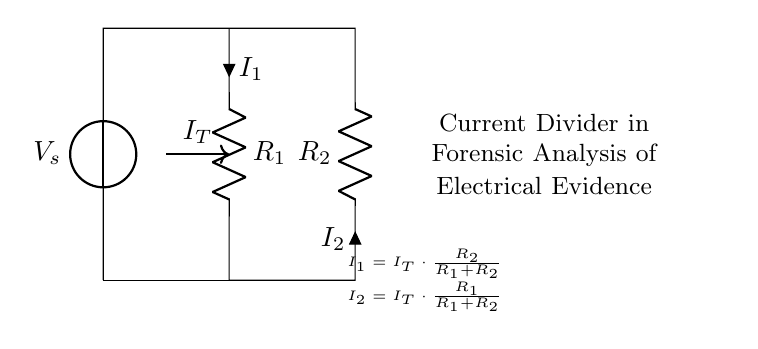What are the components present in this circuit? The components in this circuit are a voltage source and two resistors. The voltage source provides the potential difference, while the resistors divide the current.
Answer: Voltage source, two resistors What is the total current flowing in the circuit? The total current is represented as IT, which flows from the voltage source and splits between the two resistors.
Answer: IT How is current I1 related to total current IT and resistance values? Current I1 is given by the formula I1 = IT * (R2 / (R1 + R2)). This shows that I1 is directly proportional to the resistance of R2 and inversely proportional to the sum of both resistances.
Answer: IT * (R2 / (R1 + R2)) What is the relationship between currents I1 and I2? The currents I1 and I2 are inversely related to their respective resistances; as one increases, the other decreases, adhering to the principle of current division. This relationship can be expressed as I2 = IT * (R1 / (R1 + R2)).
Answer: Inversely related If R1 is 4 ohms and R2 is 2 ohms, what is the ratio of I1 to I2? To find the ratio, apply the formula: I1 / I2 = (R2 / R1) = (2 / 4) = 0.5. Thus the ratio of current I1 to I2 is 1:2, indicating I2 carries more current due to lower resistance.
Answer: 1:2 How does increasing R2 affect current I1? Increasing R2 will result in an increase in current I1 because it increases the numerator in I1’s formula (I1 = IT * (R2 / (R1 + R2))), leading to a larger current through R1 compared to I2.
Answer: Increases I1 What can be inferred about the voltage across R1 and R2? The voltage across R1 and R2 can be inferred using Ohm's Law; the voltage drop across each resistor is proportional to its resistance value and the current flowing through it. The total voltage is preserved throughout the circuit.
Answer: Proportional to their currents 